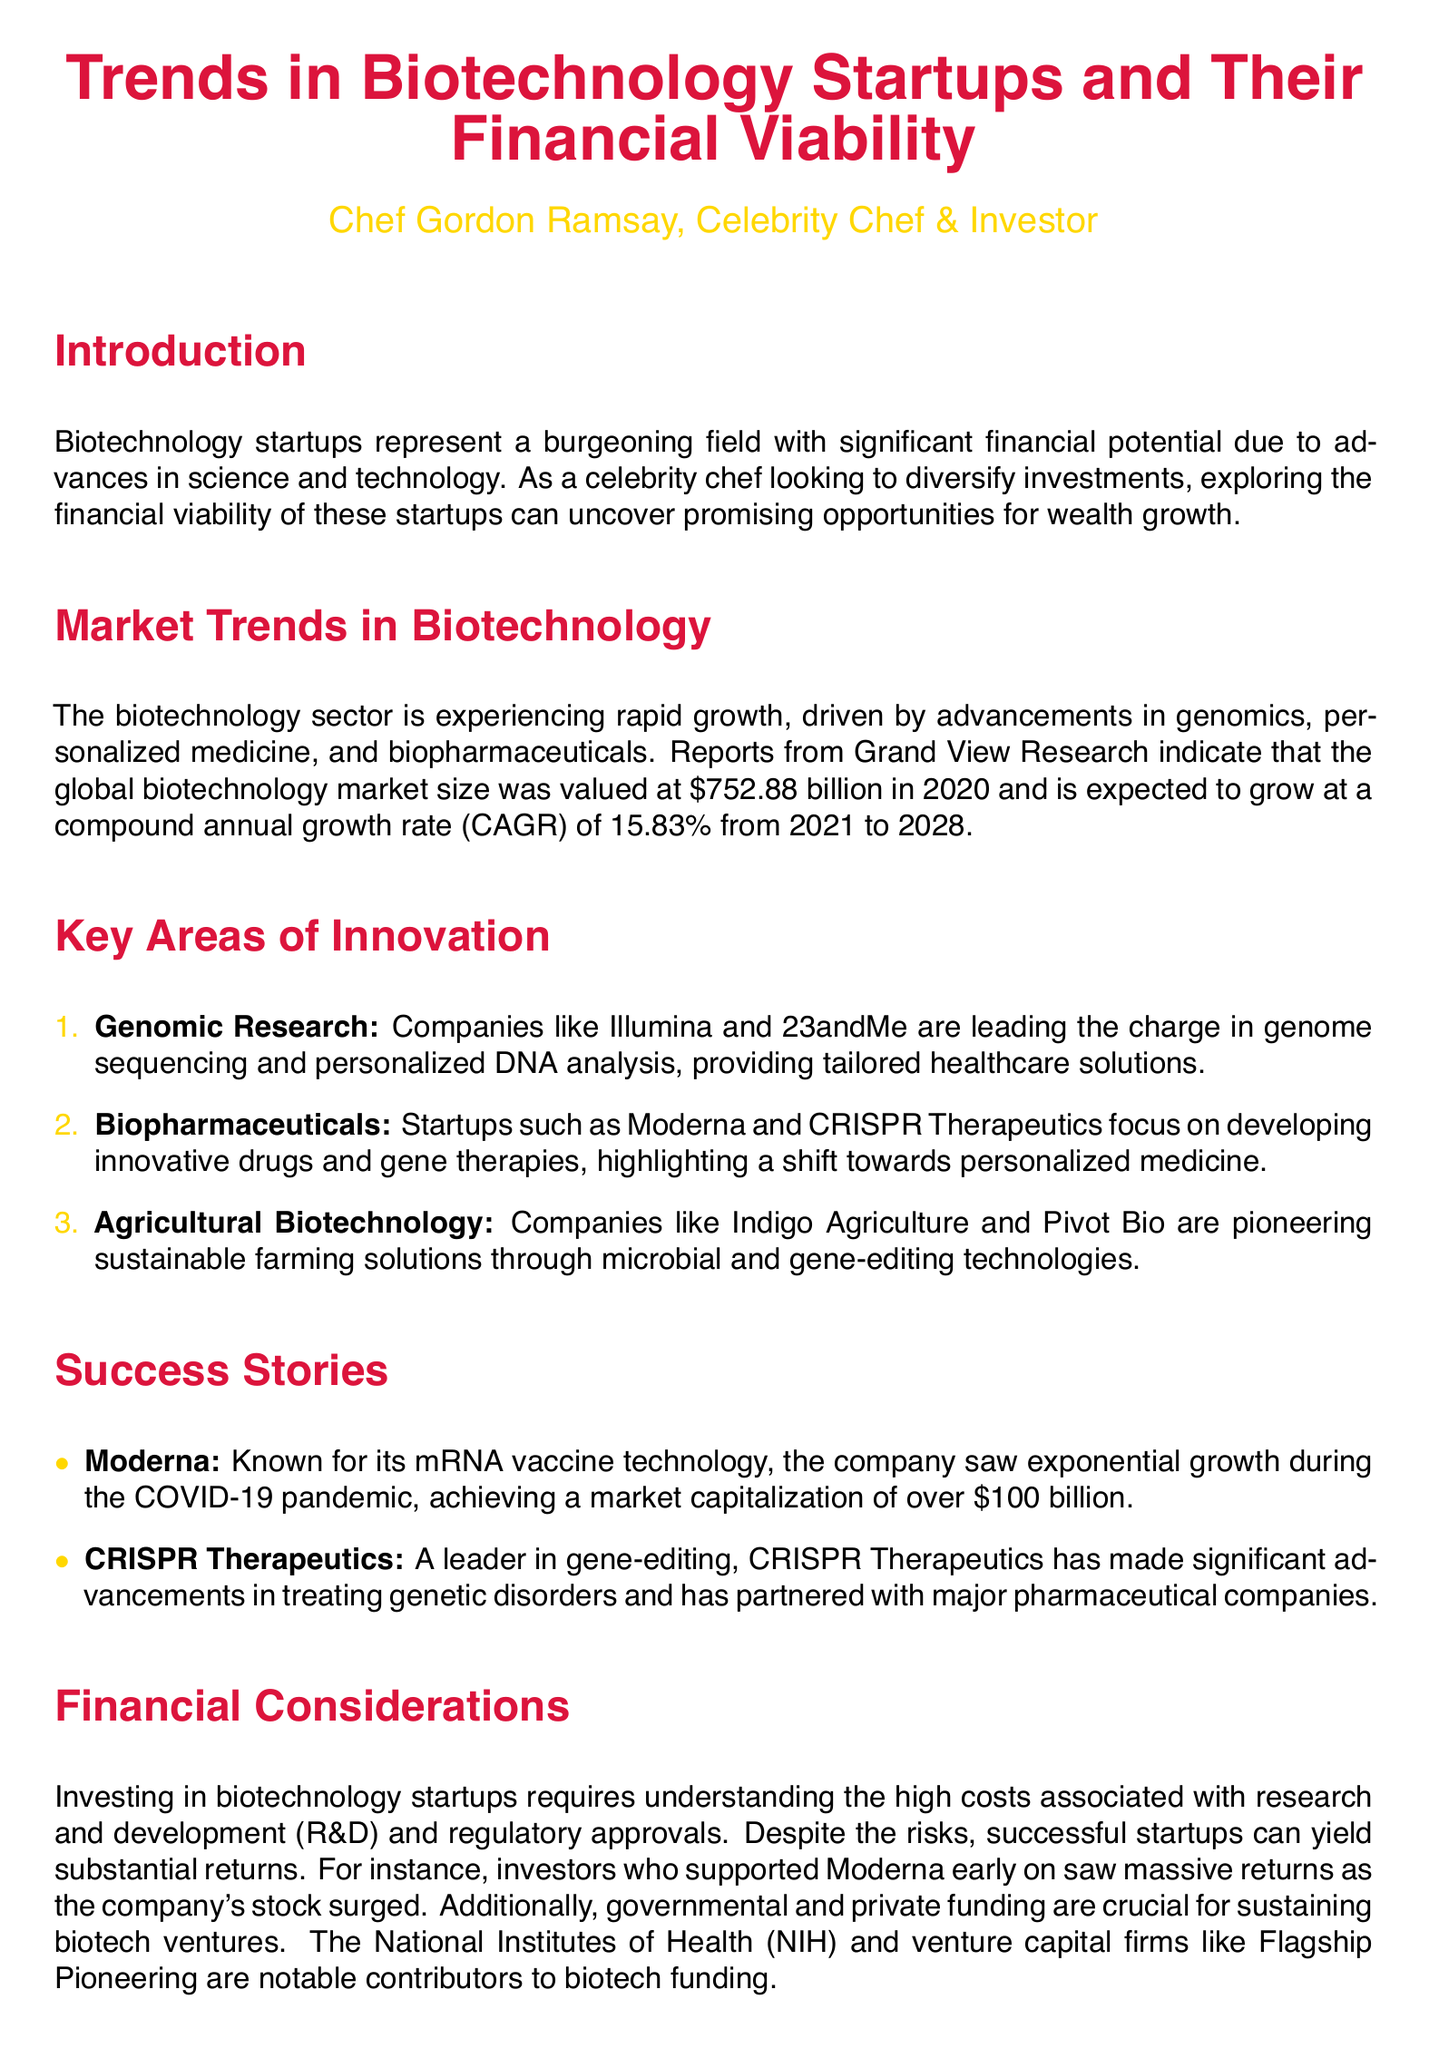What is the market size of the global biotechnology industry in 2020? The document states that the global biotechnology market size was valued at $752.88 billion in 2020.
Answer: $752.88 billion What is the expected CAGR for the biotechnology market from 2021 to 2028? The document indicates that the biotechnology market is expected to grow at a CAGR of 15.83% from 2021 to 2028.
Answer: 15.83% Which company is known for mRNA vaccine technology? The document mentions Moderna as a company known for its mRNA vaccine technology.
Answer: Moderna What key innovation area focuses on sustainable farming solutions? The document lists Agricultural Biotechnology as a key area pioneering sustainable farming solutions.
Answer: Agricultural Biotechnology What is a major source of funding for biotech startups mentioned in the document? The document references the National Institutes of Health (NIH) as a notable contributor to biotech funding.
Answer: National Institutes of Health (NIH) How much market capitalization did Moderna achieve during the COVID-19 pandemic? The document states that Moderna achieved a market capitalization of over $100 billion.
Answer: Over $100 billion What is a common challenge in investing in biotechnology startups? The document highlights the high costs associated with research and development (R&D) and regulatory approvals as a common challenge.
Answer: High costs of R&D and regulatory approvals What are the three key areas of innovation listed in the document? The document identifies Genomic Research, Biopharmaceuticals, and Agricultural Biotechnology as the three key areas of innovation.
Answer: Genomic Research, Biopharmaceuticals, Agricultural Biotechnology What type of report is this document categorized as? The document is categorized as a lab report focusing on trends in biotechnology startups and their financial viability.
Answer: Lab report 